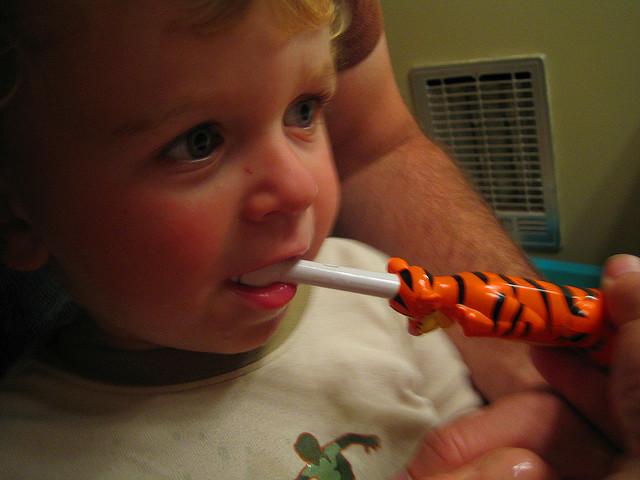Where are the toothbrushes?
Quick response, please. Mouth. What is the kid doing?
Be succinct. Brushing teeth. What color is the toothbrush?
Short answer required. Orange. What animal is on the end of the toothbrush?
Concise answer only. Tiger. Is there somebody holding the boy?
Give a very brief answer. Yes. What color is the girl's toothbrush?
Quick response, please. Orange. How many toothbrushes does the boy have?
Write a very short answer. 1. 